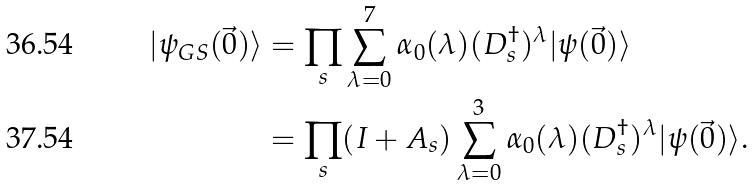<formula> <loc_0><loc_0><loc_500><loc_500>| \psi _ { G S } ( \vec { 0 } ) \rangle & = \prod _ { s } \sum _ { \lambda = 0 } ^ { 7 } \alpha _ { 0 } ( \lambda ) ( D _ { s } ^ { \dagger } ) ^ { \lambda } | \psi ( \vec { 0 } ) \rangle \\ & = \prod _ { s } ( I + A _ { s } ) \sum _ { \lambda = 0 } ^ { 3 } \alpha _ { 0 } ( \lambda ) ( D _ { s } ^ { \dagger } ) ^ { \lambda } | \psi ( \vec { 0 } ) \rangle .</formula> 